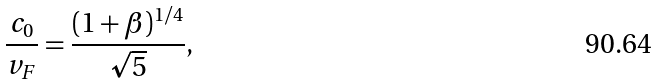<formula> <loc_0><loc_0><loc_500><loc_500>\frac { c _ { 0 } } { v _ { F } } = \frac { ( 1 + \beta ) ^ { 1 / 4 } } { \sqrt { 5 } } ,</formula> 